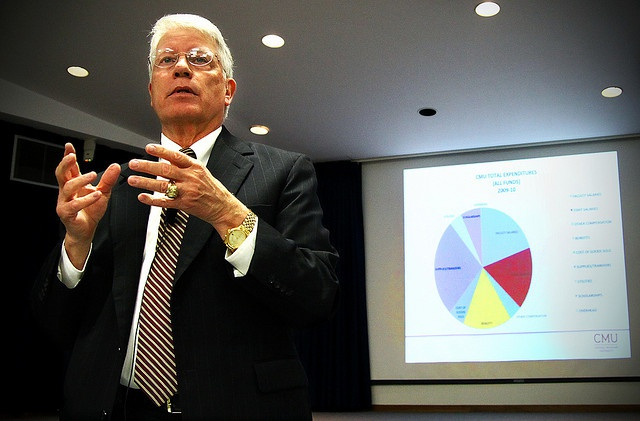Describe the objects in this image and their specific colors. I can see people in black, brown, ivory, and maroon tones, tie in black, maroon, khaki, and beige tones, and clock in black, khaki, and tan tones in this image. 